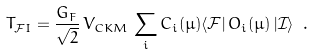Convert formula to latex. <formula><loc_0><loc_0><loc_500><loc_500>T _ { \mathcal { F } I } = \frac { G _ { F } } { \sqrt { 2 } } \, V _ { C K M } \, \sum _ { i } C _ { i } ( \mu ) \langle \mathcal { F } | \, O _ { i } ( \mu ) \, | \mathcal { I } \rangle \ .</formula> 